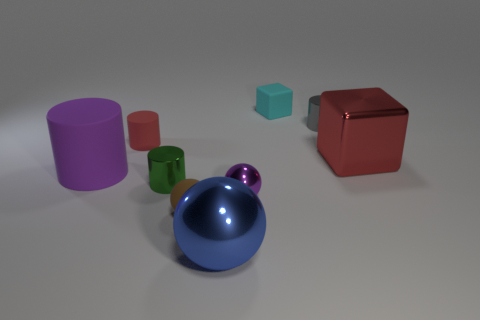Which objects in the image have reflective surfaces? The sphere and the small cylinder have reflective surfaces, noticeable by the light highlights and the visible reflections on them. 